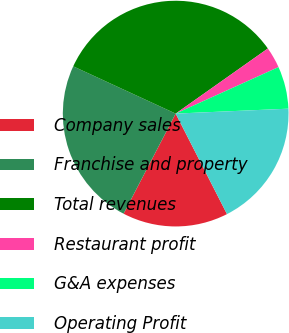Convert chart. <chart><loc_0><loc_0><loc_500><loc_500><pie_chart><fcel>Company sales<fcel>Franchise and property<fcel>Total revenues<fcel>Restaurant profit<fcel>G&A expenses<fcel>Operating Profit<nl><fcel>15.15%<fcel>24.24%<fcel>33.33%<fcel>3.03%<fcel>6.06%<fcel>18.18%<nl></chart> 